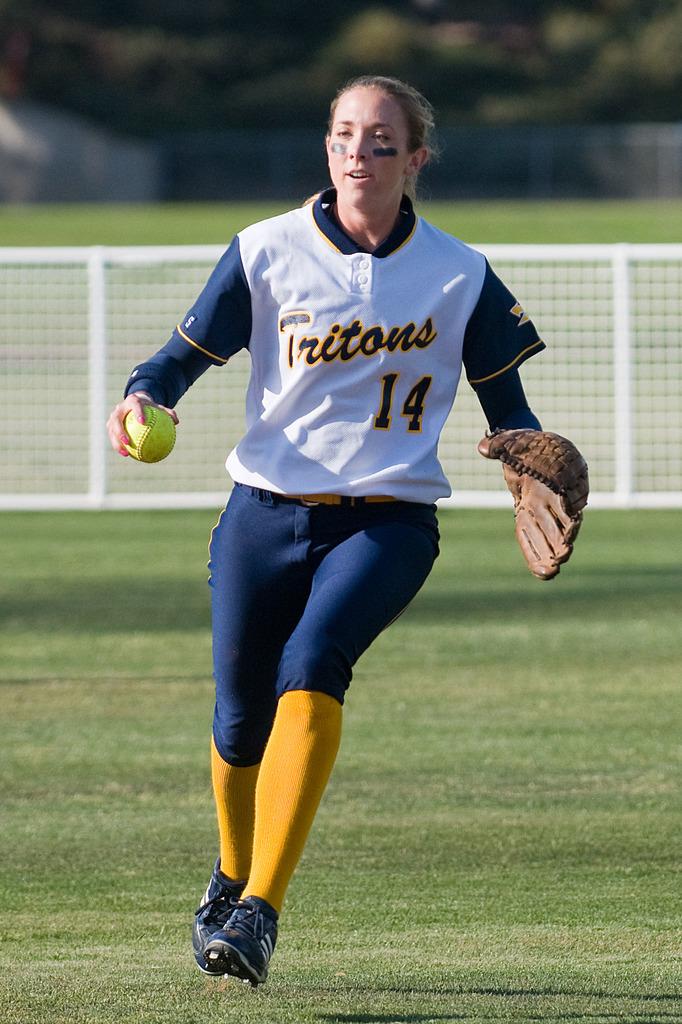What team is she on?
Your response must be concise. Tritons. 